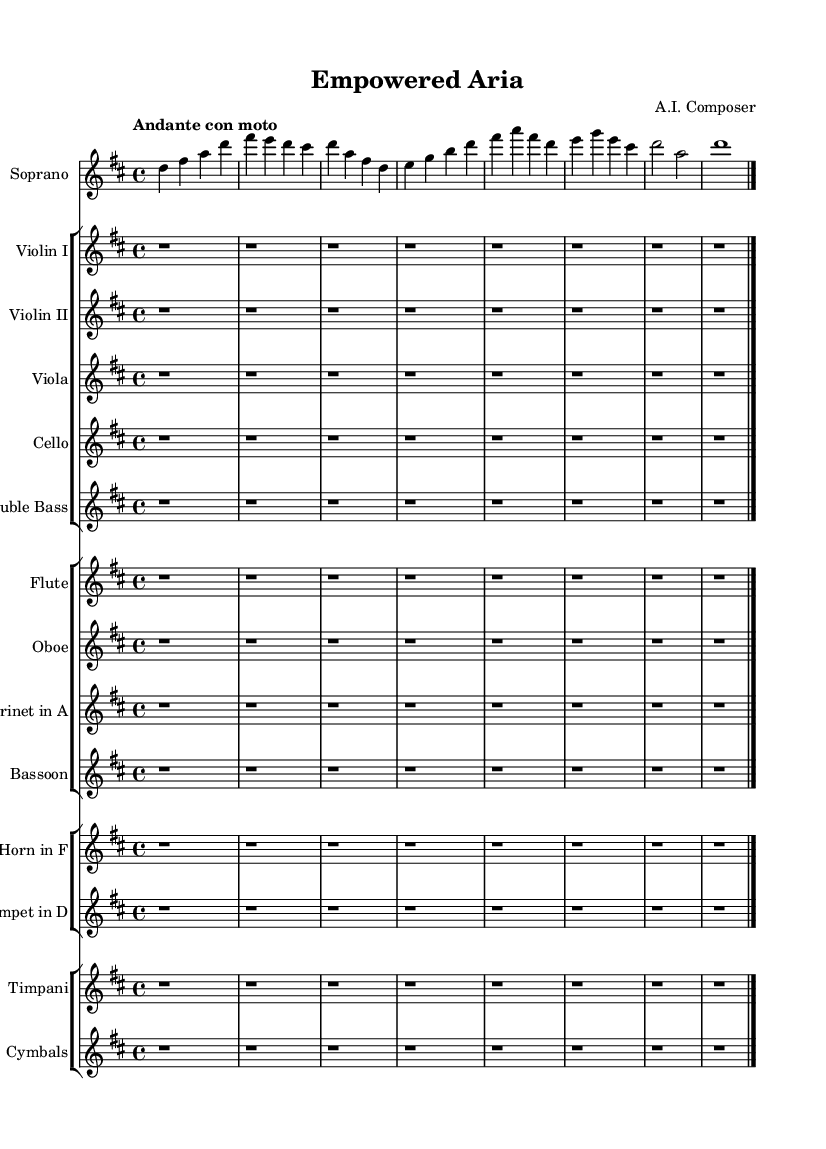What is the key signature of this music? The key signature indicates D major, which has two sharps (F# and C#). This can be identified from the key signature notation at the beginning of the score.
Answer: D major What is the time signature of this music? The time signature is displayed as 4/4 at the beginning of the score, which indicates that there are four beats in each measure and that a quarter note receives one beat.
Answer: 4/4 What is the tempo marking of this piece? The tempo marking "Andante con moto" suggests a moderately slow tempo with some movement. This is positioned at the beginning and gives performers guidance on how fast to play.
Answer: Andante con moto Which instrument is indicated as a soloist in this symphony? The 'Soprano' is labeled as the soloist within its dedicated staff. This is visually clear as it appears in the first staff of the score.
Answer: Soprano Are there any rests in the score, and if so, which instruments have them? Yes, all accompanying instruments (Violin I, Violin II, Viola, Cello, Double Bass, Flute, Oboe, Clarinet, Bassoon, Horn, Trumpet, Timpani, Cymbals) have rests for the entire section, denoted by 'r', indicating they do not play in this excerpt.
Answer: All What can be inferred about the role of the soprano in this symphony? The soprano occupies a prominent position as a soloist, evidenced by the distinct melodic lines notated above the other instruments, indicating it plays a central role in the piece.
Answer: Central role 